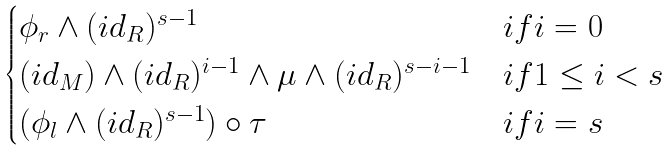Convert formula to latex. <formula><loc_0><loc_0><loc_500><loc_500>\begin{cases} \phi _ { r } \wedge ( i d _ { R } ) ^ { s - 1 } & i f i = 0 \\ ( i d _ { M } ) \wedge ( i d _ { R } ) ^ { i - 1 } \wedge \mu \wedge ( i d _ { R } ) ^ { s - i - 1 } & i f 1 \leq i < s \\ ( \phi _ { l } \wedge ( i d _ { R } ) ^ { s - 1 } ) \circ \tau & i f i = s \end{cases}</formula> 